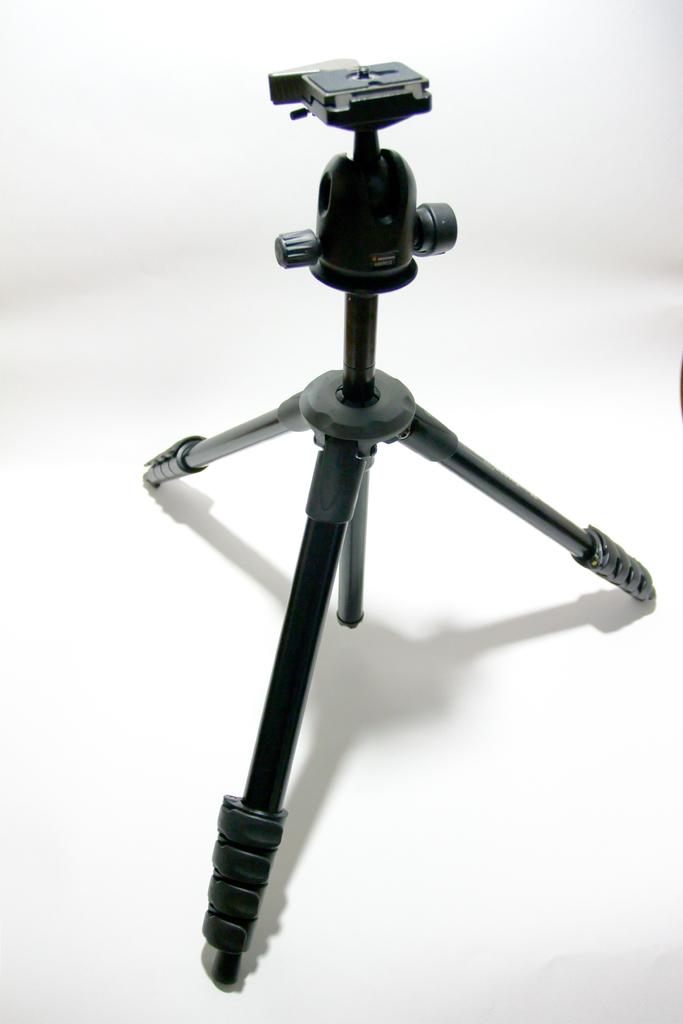What is the main object in the image? There is a camera in the image. Is there any equipment associated with the camera in the image? Yes, there is a camera stand in the image. What color is the background of the image? The background of the image is white. Reasoning: Let'g: Let's think step by step in order to produce the conversation. We start by identifying the main subject of the image, which is the camera. Then, we describe any associated equipment, which in this case is the camera stand. Finally, we mention the background color to provide a complete description of the image. Absurd Question/Answer: What type of eggnog is being used to make a connection between the camera and the stand in the image? There is no eggnog present in the image, and it is not being used to make a connection between the camera and the stand. 